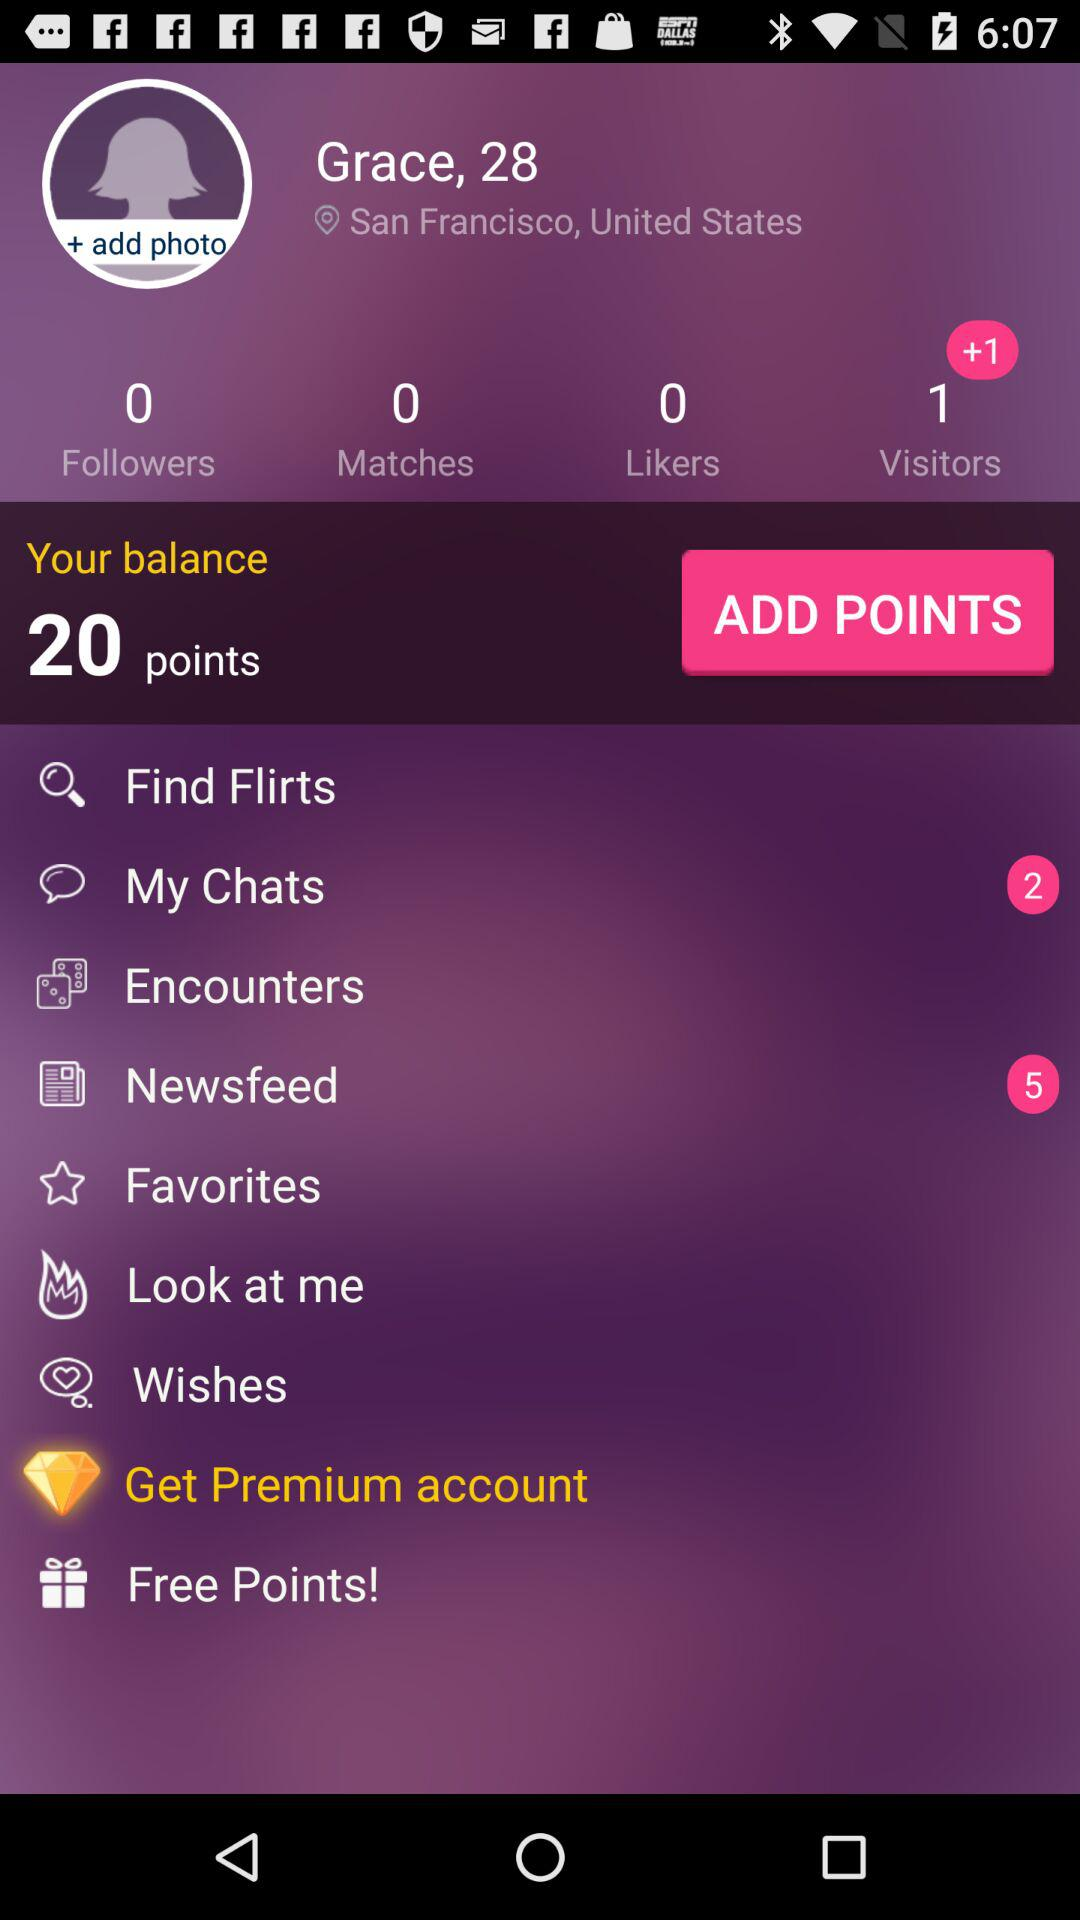How many points does Grace have?
Answer the question using a single word or phrase. 20 